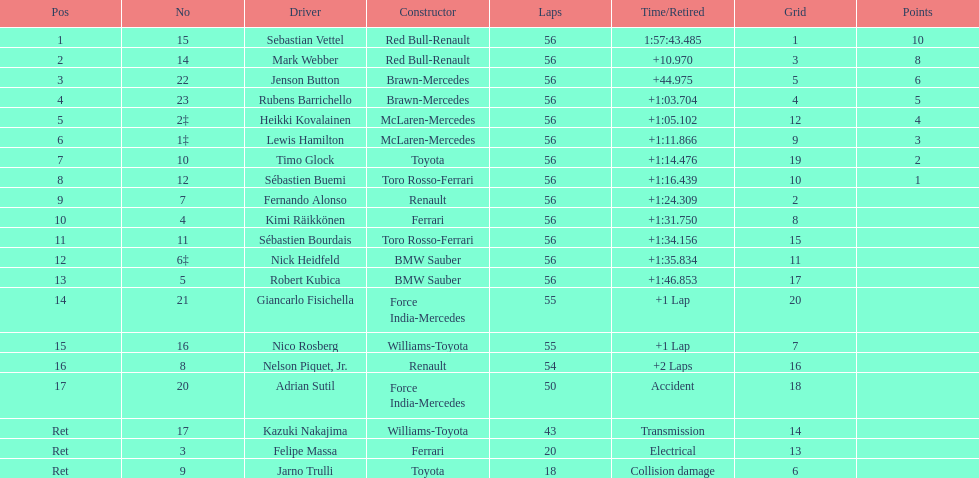What is the total number of laps in the race? 56. 